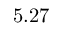Convert formula to latex. <formula><loc_0><loc_0><loc_500><loc_500>5 . 2 7</formula> 